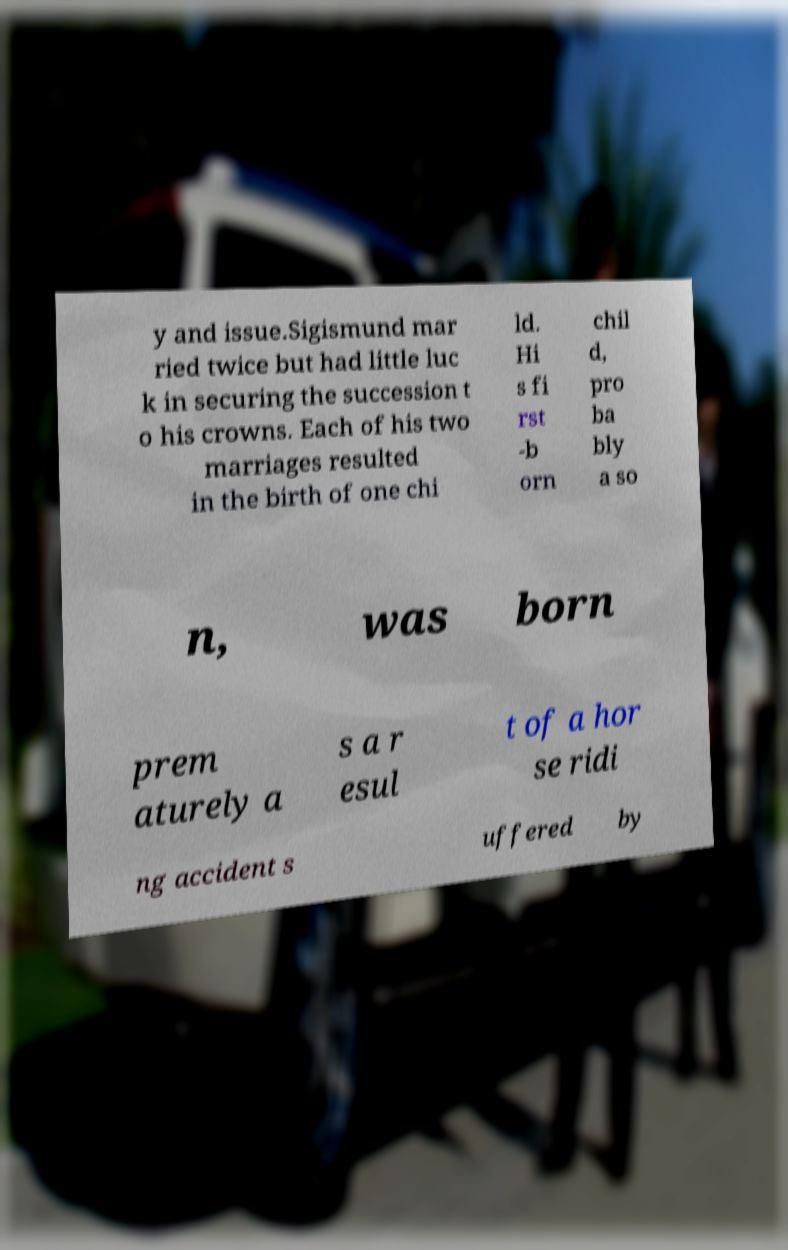I need the written content from this picture converted into text. Can you do that? y and issue.Sigismund mar ried twice but had little luc k in securing the succession t o his crowns. Each of his two marriages resulted in the birth of one chi ld. Hi s fi rst -b orn chil d, pro ba bly a so n, was born prem aturely a s a r esul t of a hor se ridi ng accident s uffered by 